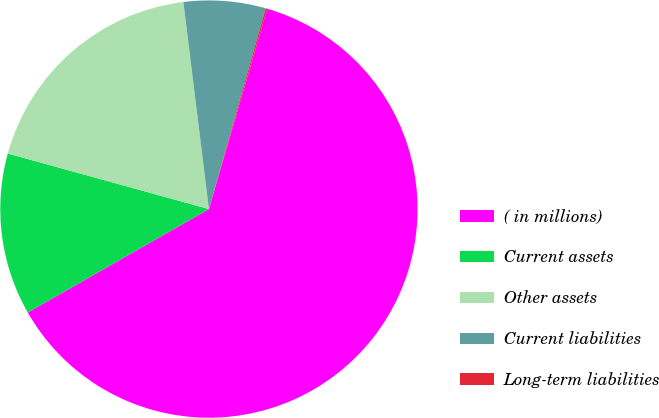Convert chart to OTSL. <chart><loc_0><loc_0><loc_500><loc_500><pie_chart><fcel>( in millions)<fcel>Current assets<fcel>Other assets<fcel>Current liabilities<fcel>Long-term liabilities<nl><fcel>62.24%<fcel>12.55%<fcel>18.76%<fcel>6.34%<fcel>0.12%<nl></chart> 